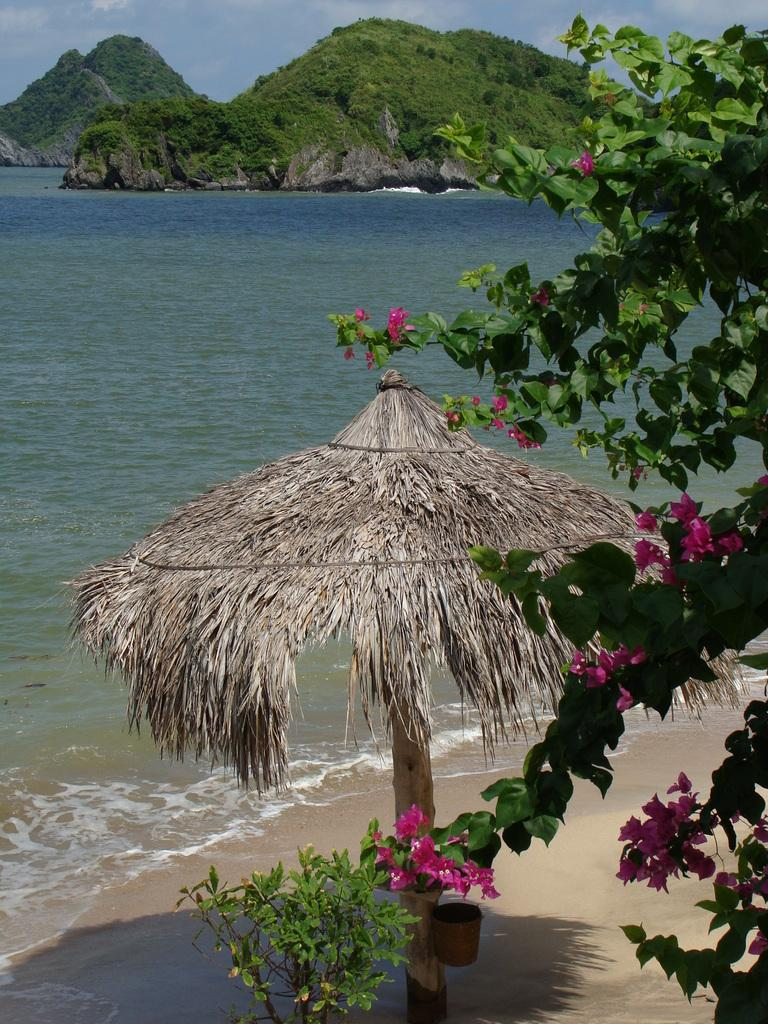What object is present in the image that is typically used for protection from rain or sun? There is an umbrella in the image. What material is the umbrella made of? The umbrella is made with dried leaves. What type of vegetation can be seen in the image? There are trees in the image. What is the color of the trees? The trees are green. What natural feature is visible in the image? Water is visible in the image. What is the color of the water? The water is blue. What else can be seen in the sky in the image? The sky is visible in the image. What is the color of the sky? The sky is blue. What type of account is being discussed in the image? There is no account being discussed in the image; it features an umbrella, trees, water, and a blue sky. How many bananas are visible in the image? There are no bananas present in the image. 